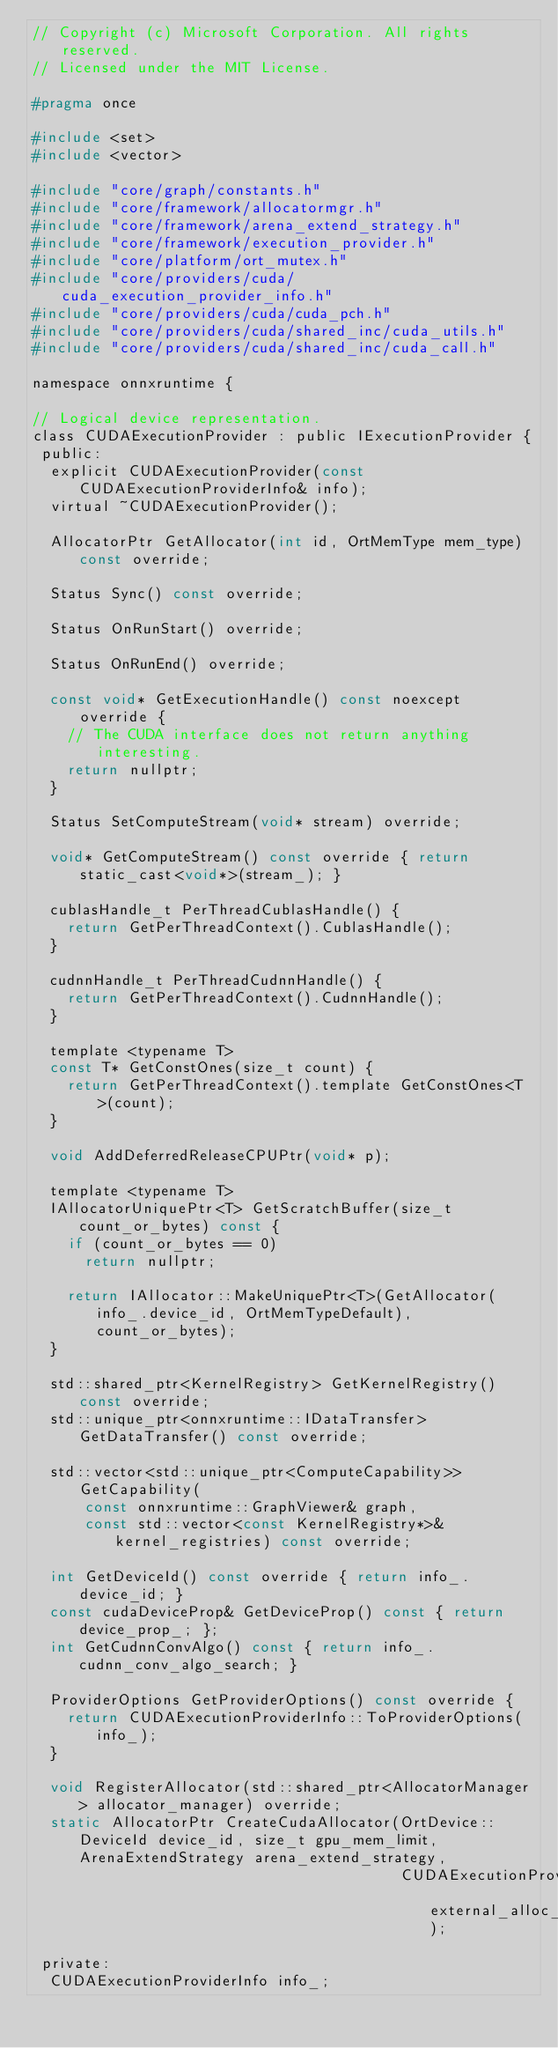<code> <loc_0><loc_0><loc_500><loc_500><_C_>// Copyright (c) Microsoft Corporation. All rights reserved.
// Licensed under the MIT License.

#pragma once

#include <set>
#include <vector>

#include "core/graph/constants.h"
#include "core/framework/allocatormgr.h"
#include "core/framework/arena_extend_strategy.h"
#include "core/framework/execution_provider.h"
#include "core/platform/ort_mutex.h"
#include "core/providers/cuda/cuda_execution_provider_info.h"
#include "core/providers/cuda/cuda_pch.h"
#include "core/providers/cuda/shared_inc/cuda_utils.h"
#include "core/providers/cuda/shared_inc/cuda_call.h"

namespace onnxruntime {

// Logical device representation.
class CUDAExecutionProvider : public IExecutionProvider {
 public:
  explicit CUDAExecutionProvider(const CUDAExecutionProviderInfo& info);
  virtual ~CUDAExecutionProvider();

  AllocatorPtr GetAllocator(int id, OrtMemType mem_type) const override;

  Status Sync() const override;

  Status OnRunStart() override;

  Status OnRunEnd() override;

  const void* GetExecutionHandle() const noexcept override {
    // The CUDA interface does not return anything interesting.
    return nullptr;
  }

  Status SetComputeStream(void* stream) override;

  void* GetComputeStream() const override { return static_cast<void*>(stream_); }

  cublasHandle_t PerThreadCublasHandle() {
    return GetPerThreadContext().CublasHandle();
  }

  cudnnHandle_t PerThreadCudnnHandle() {
    return GetPerThreadContext().CudnnHandle();
  }

  template <typename T>
  const T* GetConstOnes(size_t count) {
    return GetPerThreadContext().template GetConstOnes<T>(count);
  }

  void AddDeferredReleaseCPUPtr(void* p);

  template <typename T>
  IAllocatorUniquePtr<T> GetScratchBuffer(size_t count_or_bytes) const {
    if (count_or_bytes == 0)
      return nullptr;

    return IAllocator::MakeUniquePtr<T>(GetAllocator(info_.device_id, OrtMemTypeDefault), count_or_bytes);
  }

  std::shared_ptr<KernelRegistry> GetKernelRegistry() const override;
  std::unique_ptr<onnxruntime::IDataTransfer> GetDataTransfer() const override;

  std::vector<std::unique_ptr<ComputeCapability>> GetCapability(
      const onnxruntime::GraphViewer& graph,
      const std::vector<const KernelRegistry*>& kernel_registries) const override;

  int GetDeviceId() const override { return info_.device_id; }
  const cudaDeviceProp& GetDeviceProp() const { return device_prop_; };
  int GetCudnnConvAlgo() const { return info_.cudnn_conv_algo_search; }

  ProviderOptions GetProviderOptions() const override {
    return CUDAExecutionProviderInfo::ToProviderOptions(info_);
  }

  void RegisterAllocator(std::shared_ptr<AllocatorManager> allocator_manager) override;
  static AllocatorPtr CreateCudaAllocator(OrtDevice::DeviceId device_id, size_t gpu_mem_limit, ArenaExtendStrategy arena_extend_strategy,
                                          CUDAExecutionProviderExternalAllocatorInfo external_alloc_info);

 private:
  CUDAExecutionProviderInfo info_;</code> 